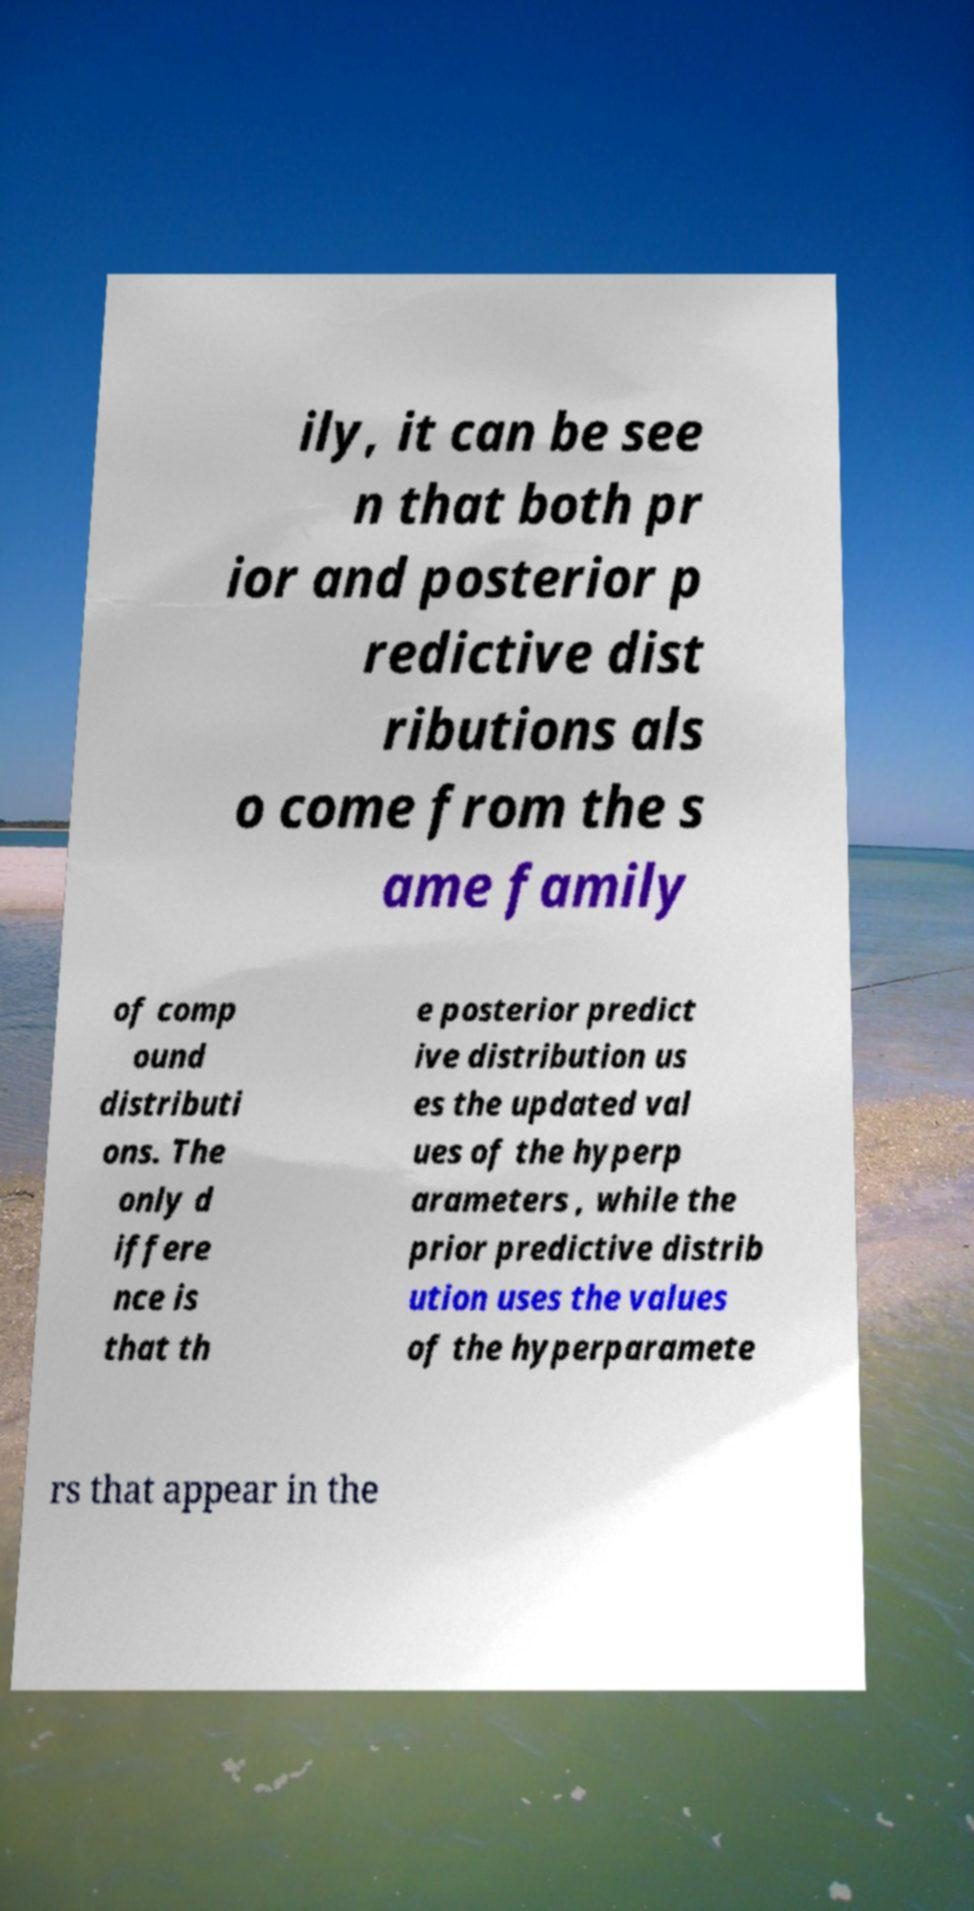Can you accurately transcribe the text from the provided image for me? ily, it can be see n that both pr ior and posterior p redictive dist ributions als o come from the s ame family of comp ound distributi ons. The only d iffere nce is that th e posterior predict ive distribution us es the updated val ues of the hyperp arameters , while the prior predictive distrib ution uses the values of the hyperparamete rs that appear in the 